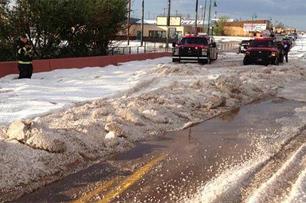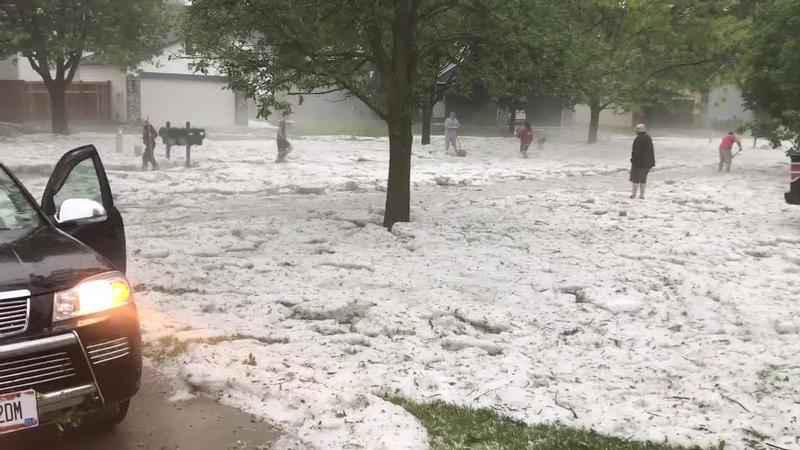The first image is the image on the left, the second image is the image on the right. Examine the images to the left and right. Is the description "In the right image a snow plow is plowing snow." accurate? Answer yes or no. No. 